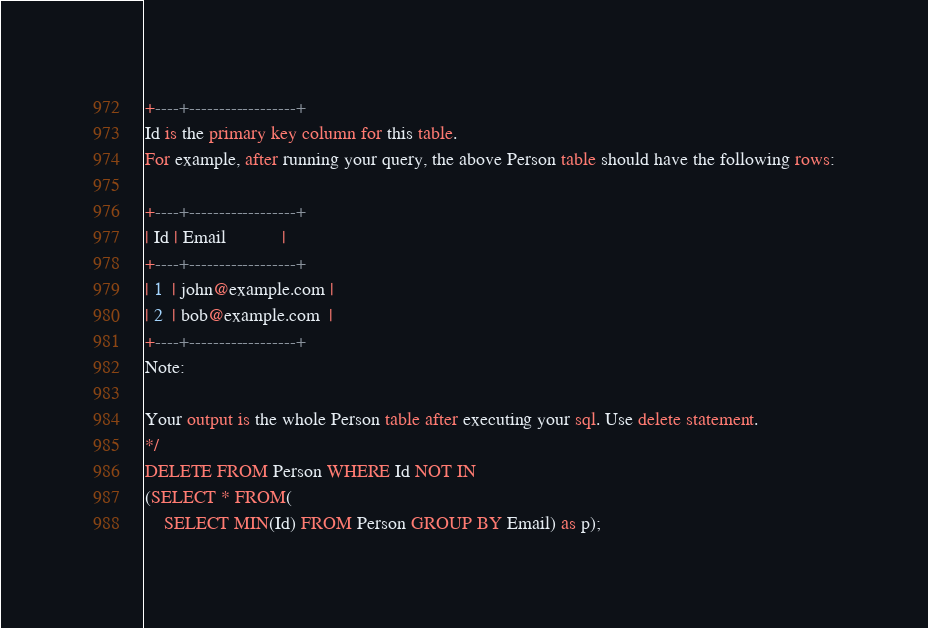<code> <loc_0><loc_0><loc_500><loc_500><_SQL_>+----+------------------+
Id is the primary key column for this table.
For example, after running your query, the above Person table should have the following rows:

+----+------------------+
| Id | Email            |
+----+------------------+
| 1  | john@example.com |
| 2  | bob@example.com  |
+----+------------------+
Note:

Your output is the whole Person table after executing your sql. Use delete statement.
*/
DELETE FROM Person WHERE Id NOT IN 
(SELECT * FROM(
    SELECT MIN(Id) FROM Person GROUP BY Email) as p);
</code> 